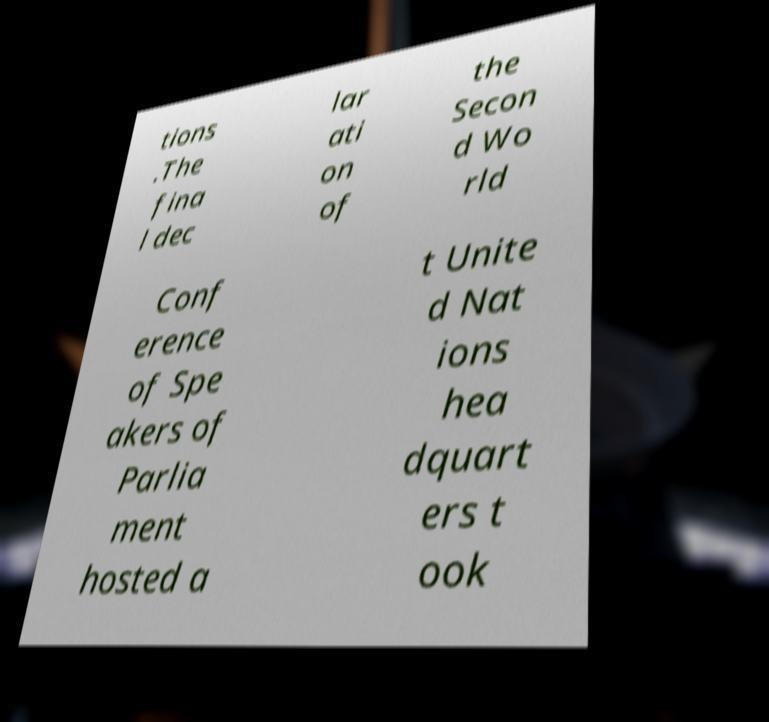There's text embedded in this image that I need extracted. Can you transcribe it verbatim? tions .The fina l dec lar ati on of the Secon d Wo rld Conf erence of Spe akers of Parlia ment hosted a t Unite d Nat ions hea dquart ers t ook 